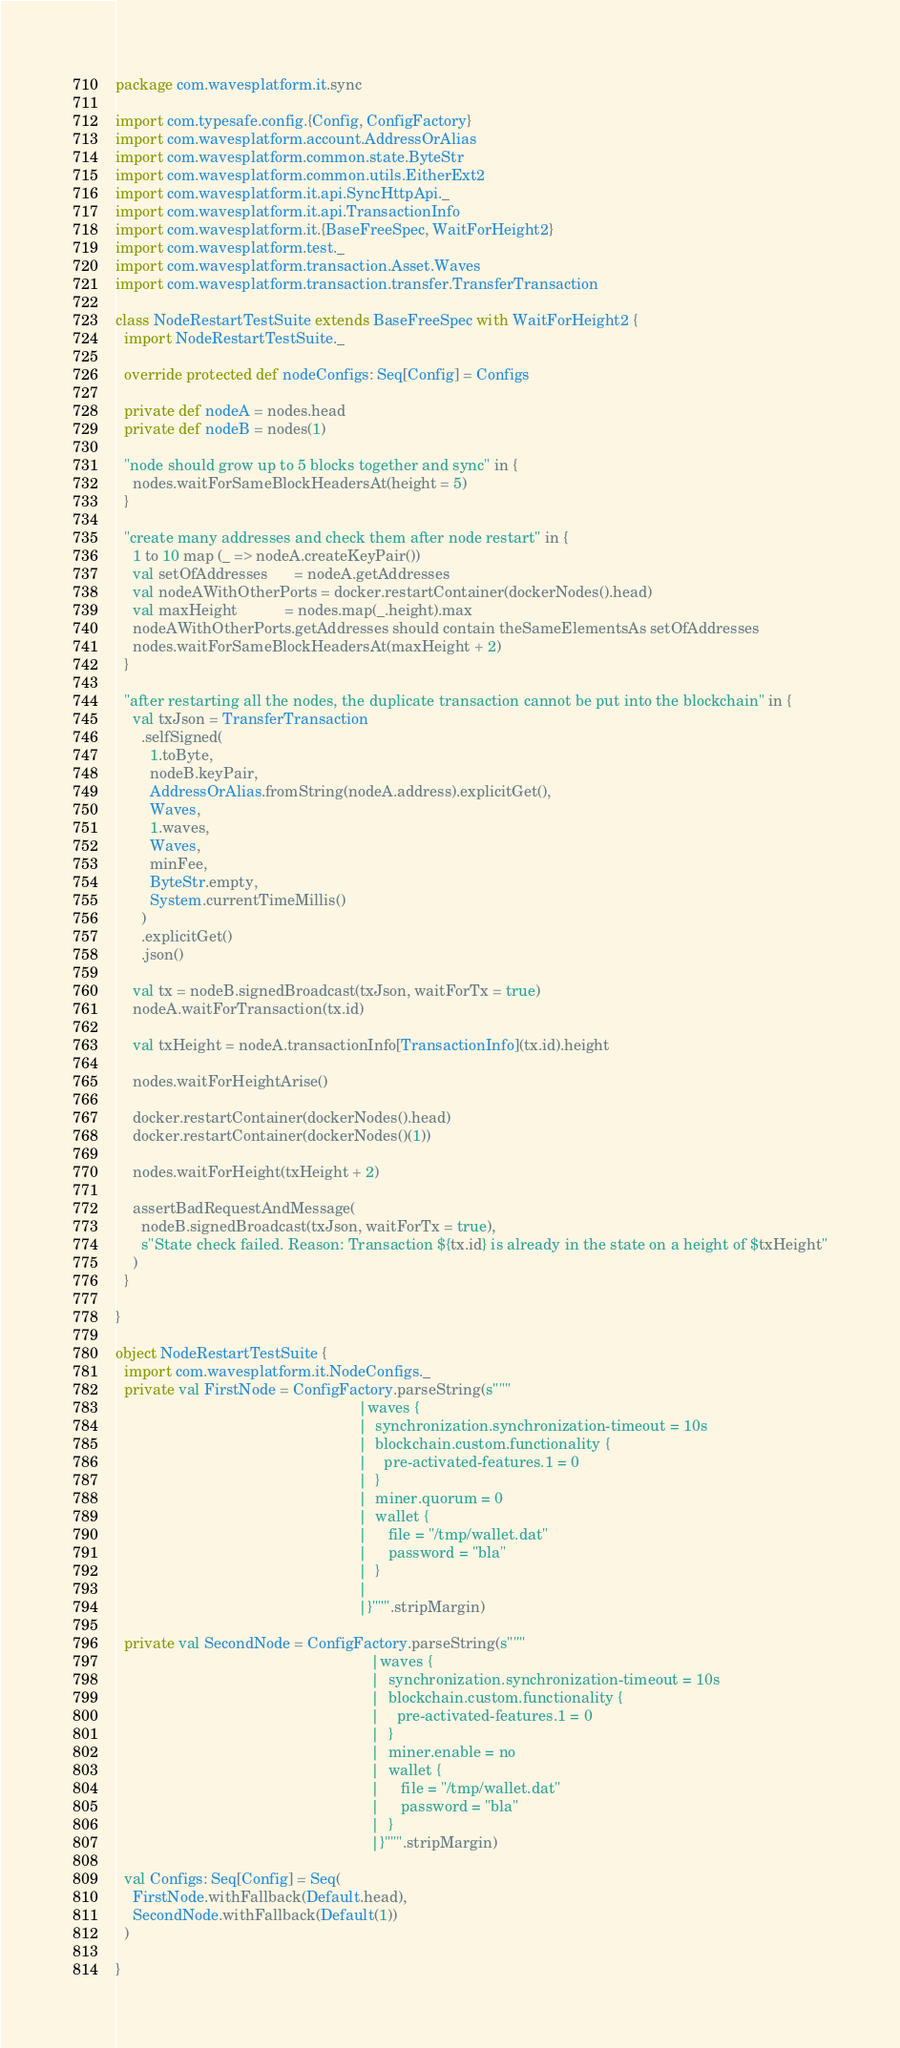Convert code to text. <code><loc_0><loc_0><loc_500><loc_500><_Scala_>package com.wavesplatform.it.sync

import com.typesafe.config.{Config, ConfigFactory}
import com.wavesplatform.account.AddressOrAlias
import com.wavesplatform.common.state.ByteStr
import com.wavesplatform.common.utils.EitherExt2
import com.wavesplatform.it.api.SyncHttpApi._
import com.wavesplatform.it.api.TransactionInfo
import com.wavesplatform.it.{BaseFreeSpec, WaitForHeight2}
import com.wavesplatform.test._
import com.wavesplatform.transaction.Asset.Waves
import com.wavesplatform.transaction.transfer.TransferTransaction

class NodeRestartTestSuite extends BaseFreeSpec with WaitForHeight2 {
  import NodeRestartTestSuite._

  override protected def nodeConfigs: Seq[Config] = Configs

  private def nodeA = nodes.head
  private def nodeB = nodes(1)

  "node should grow up to 5 blocks together and sync" in {
    nodes.waitForSameBlockHeadersAt(height = 5)
  }

  "create many addresses and check them after node restart" in {
    1 to 10 map (_ => nodeA.createKeyPair())
    val setOfAddresses      = nodeA.getAddresses
    val nodeAWithOtherPorts = docker.restartContainer(dockerNodes().head)
    val maxHeight           = nodes.map(_.height).max
    nodeAWithOtherPorts.getAddresses should contain theSameElementsAs setOfAddresses
    nodes.waitForSameBlockHeadersAt(maxHeight + 2)
  }

  "after restarting all the nodes, the duplicate transaction cannot be put into the blockchain" in {
    val txJson = TransferTransaction
      .selfSigned(
        1.toByte,
        nodeB.keyPair,
        AddressOrAlias.fromString(nodeA.address).explicitGet(),
        Waves,
        1.waves,
        Waves,
        minFee,
        ByteStr.empty,
        System.currentTimeMillis()
      )
      .explicitGet()
      .json()

    val tx = nodeB.signedBroadcast(txJson, waitForTx = true)
    nodeA.waitForTransaction(tx.id)

    val txHeight = nodeA.transactionInfo[TransactionInfo](tx.id).height

    nodes.waitForHeightArise()

    docker.restartContainer(dockerNodes().head)
    docker.restartContainer(dockerNodes()(1))

    nodes.waitForHeight(txHeight + 2)

    assertBadRequestAndMessage(
      nodeB.signedBroadcast(txJson, waitForTx = true),
      s"State check failed. Reason: Transaction ${tx.id} is already in the state on a height of $txHeight"
    )
  }

}

object NodeRestartTestSuite {
  import com.wavesplatform.it.NodeConfigs._
  private val FirstNode = ConfigFactory.parseString(s"""
                                                         |waves {
                                                         |  synchronization.synchronization-timeout = 10s
                                                         |  blockchain.custom.functionality {
                                                         |    pre-activated-features.1 = 0
                                                         |  }
                                                         |  miner.quorum = 0
                                                         |  wallet {
                                                         |     file = "/tmp/wallet.dat"
                                                         |     password = "bla"
                                                         |  }
                                                         |
                                                         |}""".stripMargin)

  private val SecondNode = ConfigFactory.parseString(s"""
                                                            |waves {
                                                            |  synchronization.synchronization-timeout = 10s
                                                            |  blockchain.custom.functionality {
                                                            |    pre-activated-features.1 = 0
                                                            |  }
                                                            |  miner.enable = no
                                                            |  wallet {
                                                            |     file = "/tmp/wallet.dat"
                                                            |     password = "bla"
                                                            |  }
                                                            |}""".stripMargin)

  val Configs: Seq[Config] = Seq(
    FirstNode.withFallback(Default.head),
    SecondNode.withFallback(Default(1))
  )

}
</code> 